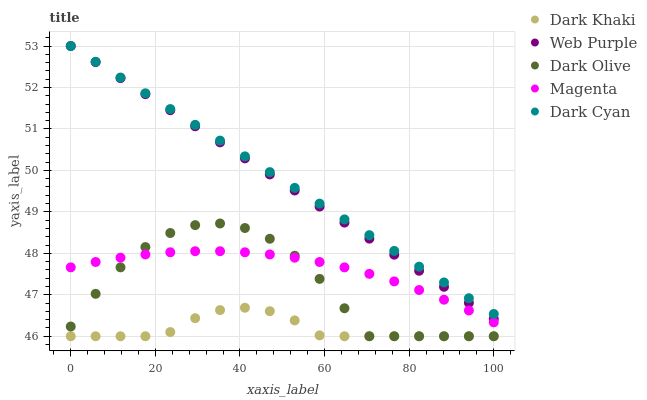Does Dark Khaki have the minimum area under the curve?
Answer yes or no. Yes. Does Dark Cyan have the maximum area under the curve?
Answer yes or no. Yes. Does Web Purple have the minimum area under the curve?
Answer yes or no. No. Does Web Purple have the maximum area under the curve?
Answer yes or no. No. Is Web Purple the smoothest?
Answer yes or no. Yes. Is Dark Olive the roughest?
Answer yes or no. Yes. Is Dark Cyan the smoothest?
Answer yes or no. No. Is Dark Cyan the roughest?
Answer yes or no. No. Does Dark Khaki have the lowest value?
Answer yes or no. Yes. Does Web Purple have the lowest value?
Answer yes or no. No. Does Web Purple have the highest value?
Answer yes or no. Yes. Does Dark Olive have the highest value?
Answer yes or no. No. Is Dark Khaki less than Magenta?
Answer yes or no. Yes. Is Dark Cyan greater than Magenta?
Answer yes or no. Yes. Does Dark Cyan intersect Web Purple?
Answer yes or no. Yes. Is Dark Cyan less than Web Purple?
Answer yes or no. No. Is Dark Cyan greater than Web Purple?
Answer yes or no. No. Does Dark Khaki intersect Magenta?
Answer yes or no. No. 